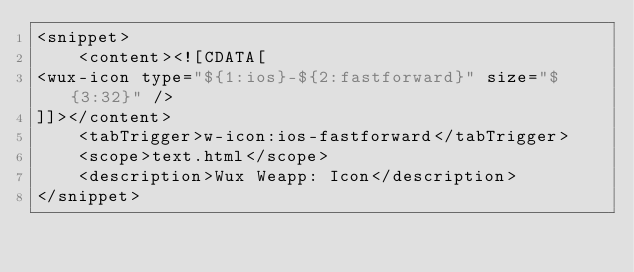<code> <loc_0><loc_0><loc_500><loc_500><_XML_><snippet>
	<content><![CDATA[
<wux-icon type="${1:ios}-${2:fastforward}" size="${3:32}" />
]]></content>
	<tabTrigger>w-icon:ios-fastforward</tabTrigger>
	<scope>text.html</scope>
	<description>Wux Weapp: Icon</description>
</snippet></code> 